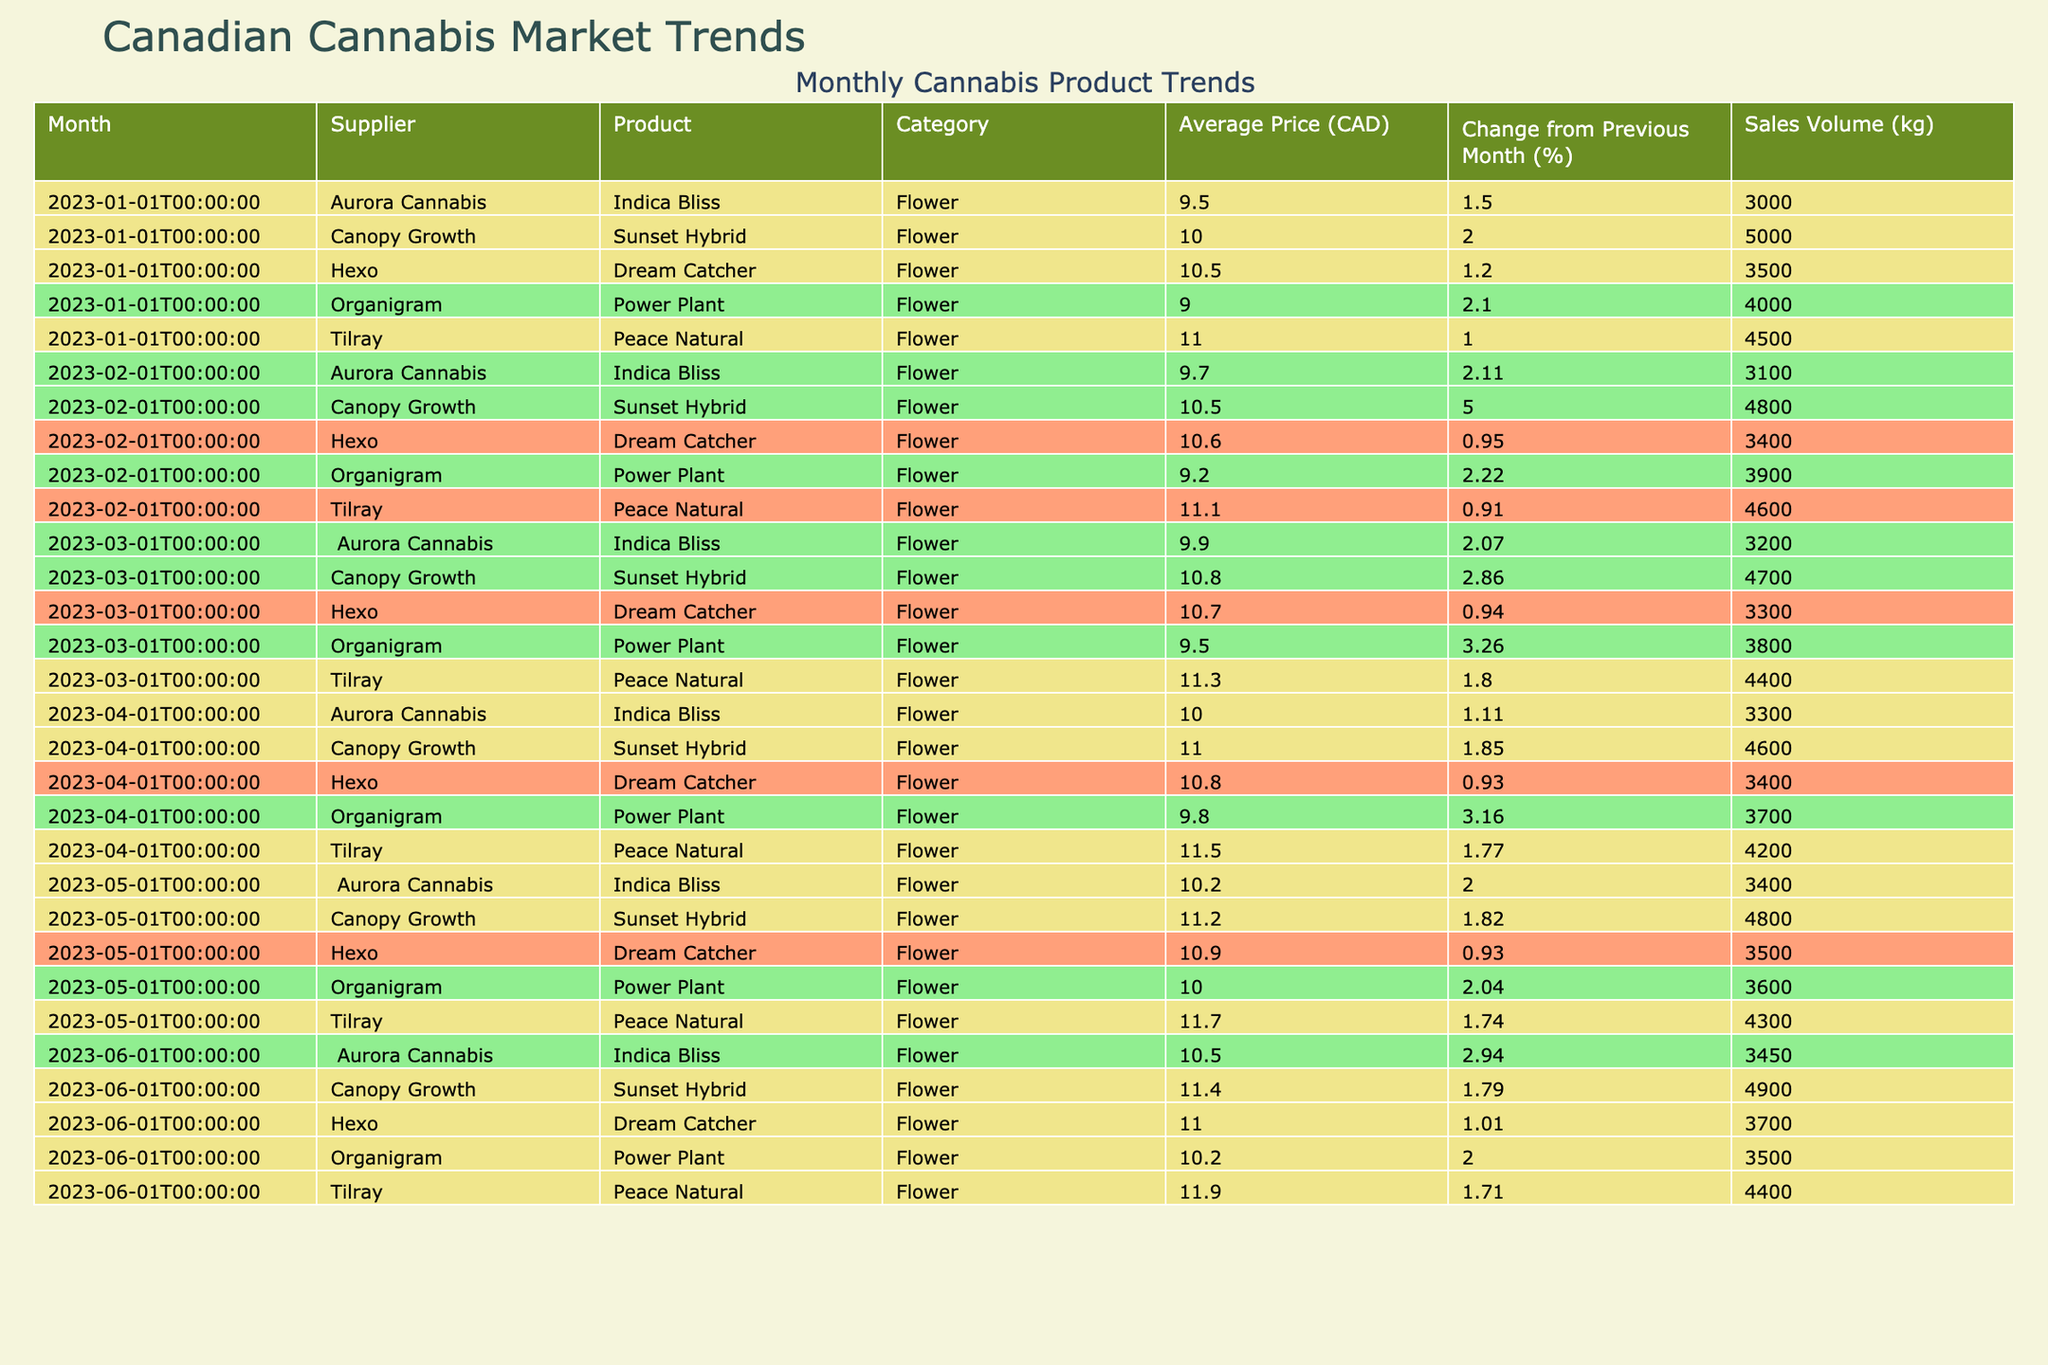What was the average price of Tilray's Peace Natural in May 2023? The average price of Tilray's Peace Natural in May 2023 is 11.70 CAD.
Answer: 11.70 CAD Which supplier had the highest average price for their product in June 2023? In June 2023, Tilray had the highest average price for their product, which was 11.90 CAD for Peace Natural.
Answer: Tilray What was the percentage change in price for Canopy Growth's Sunset Hybrid from January to June 2023? Canopy Growth's Sunset Hybrid had an average price of 10.00 CAD in January and 11.40 CAD in June, which is a change of 14% ((11.40 - 10.00)/10.00 * 100).
Answer: 14% Did Aurora Cannabis' Indica Bliss see a decrease in sales volume from January to April 2023? Yes, the sales volume for Aurora Cannabis' Indica Bliss decreased from 3000 kg in January to 3300 kg in April, indicating an increase; therefore, the statement is false.
Answer: No What is the sum of the average prices for all products from Organigram between January and June 2023? From January to June 2023, the average prices for Organigram's Power Plant are 9.00, 9.20, 9.50, 9.80, and 10.00 CAD respectively, leading to a sum: 9.00 + 9.20 + 9.50 + 9.80 + 10.00 = 47.50 CAD.
Answer: 47.50 CAD Which product had the most consistent price increase over the first five months of 2023? By analyzing the price changes month by month, Canopy Growth's Sunset Hybrid consistently increased from 10.00 CAD in January to 11.40 CAD in June.
Answer: Canopy Growth's Sunset Hybrid What was the change in price from March to April for Hexo's Dream Catcher? In March, Hexo's Dream Catcher was priced at 10.70 CAD, while in April it was 10.80 CAD. The change is 0.10 CAD, which is an increase of about 0.93%.
Answer: 0.10 CAD increase Was there any month where Organigram's average price changed by more than 3%? Yes, in March, Organigram's average price changed by 3.26% compared to February.
Answer: Yes Calculate the average sales volume of Tilray's Peace Natural over the first half of 2023. In the first half of 2023, the sales volumes for Tilray's Peace Natural were 4500, 4600, 4400, 4200, and 4300 kg, with an average of (4500 + 4600 + 4400 + 4200 + 4300) / 5 = 4400 kg.
Answer: 4400 kg What was the lowest average price of any product in January 2023? In January 2023, the lowest average price was 9.00 CAD for Organigram's Power Plant.
Answer: 9.00 CAD 